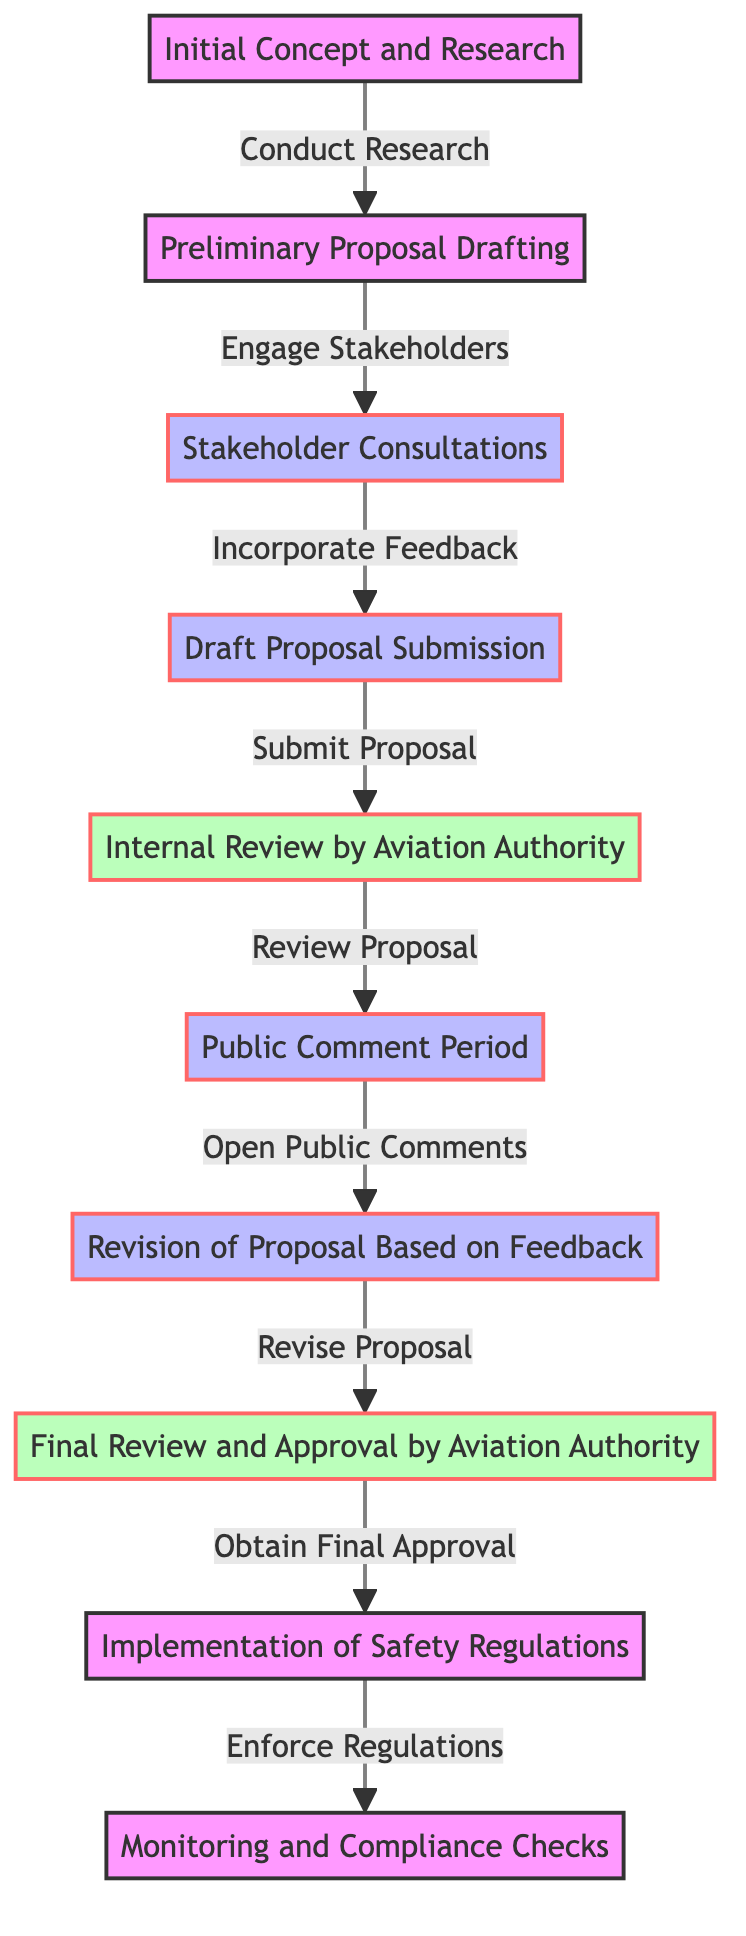What is the first step in the development process? The first step as represented in the diagram is "Initial Concept and Research". It is located at the top of the directed graph, indicating the starting point of the process.
Answer: Initial Concept and Research How many nodes are present in the diagram? The diagram contains a total of ten nodes representing different stages in the development process and approval stages of aviation safety regulations. This is derived from listing all the unique labeled stages in the diagram.
Answer: Ten What is the relationship between the "Draft Proposal Submission" and the "Public Comment Period"? The relationship indicates that "Draft Proposal Submission" leads to "Public Comment Period". According to the edges, "Draft Proposal Submission" connects directly to "Internal Review by Aviation Authority", which then leads to the "Public Comment Period".
Answer: Submit Proposal Which step follows "Final Review and Approval by Aviation Authority"? According to the flow of the diagram, the step that follows "Final Review and Approval by Aviation Authority" is "Implementation of Safety Regulations." This is based on the direct path drawn in the diagram leading to the next node.
Answer: Implementation of Safety Regulations How many edges are there in the diagram? To find the number of edges, we count the connections between nodes, leading us to a total of nine edges that represent the various relationships and transitions from one step to another in the diagram.
Answer: Nine What feedback is incorporated after the "Stakeholder Consultations"? After the "Stakeholder Consultations", the feedback incorporated is done in the "Draft Proposal Submission". This is shown by the directed flow in the diagram which indicates that stakeholder input directly influences the drafting stage.
Answer: Incorporate Feedback What stage comes before the "Internal Review by Aviation Authority"? The stage that comes before the "Internal Review by Aviation Authority" is "Draft Proposal Submission". This is established by looking at the directional edge leading into the "Internal Review by Aviation Authority" node.
Answer: Draft Proposal Submission What action is taken during the "Public Comment Period"? During the "Public Comment Period", the action taken is "Open Public Comments" which indicates that this step allows for public input on the proposal. This is noted in the edge leading into "Revision of Proposal Based on Feedback".
Answer: Open Public Comments What is the last step in the diagram? The last step illustrated in the diagram is "Monitoring and Compliance Checks". It follows the implementation of regulations signifying an ongoing process to ensure adherence to the newly established safety regulations.
Answer: Monitoring and Compliance Checks 